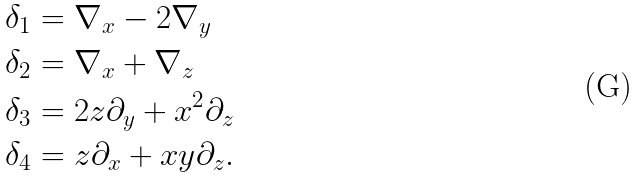<formula> <loc_0><loc_0><loc_500><loc_500>& \delta _ { 1 } = \nabla _ { x } - 2 \nabla _ { y } \\ & \delta _ { 2 } = \nabla _ { x } + \nabla _ { z } \\ & \delta _ { 3 } = 2 z \partial _ { y } + x ^ { 2 } \partial _ { z } \\ & \delta _ { 4 } = z \partial _ { x } + x y \partial _ { z } .</formula> 